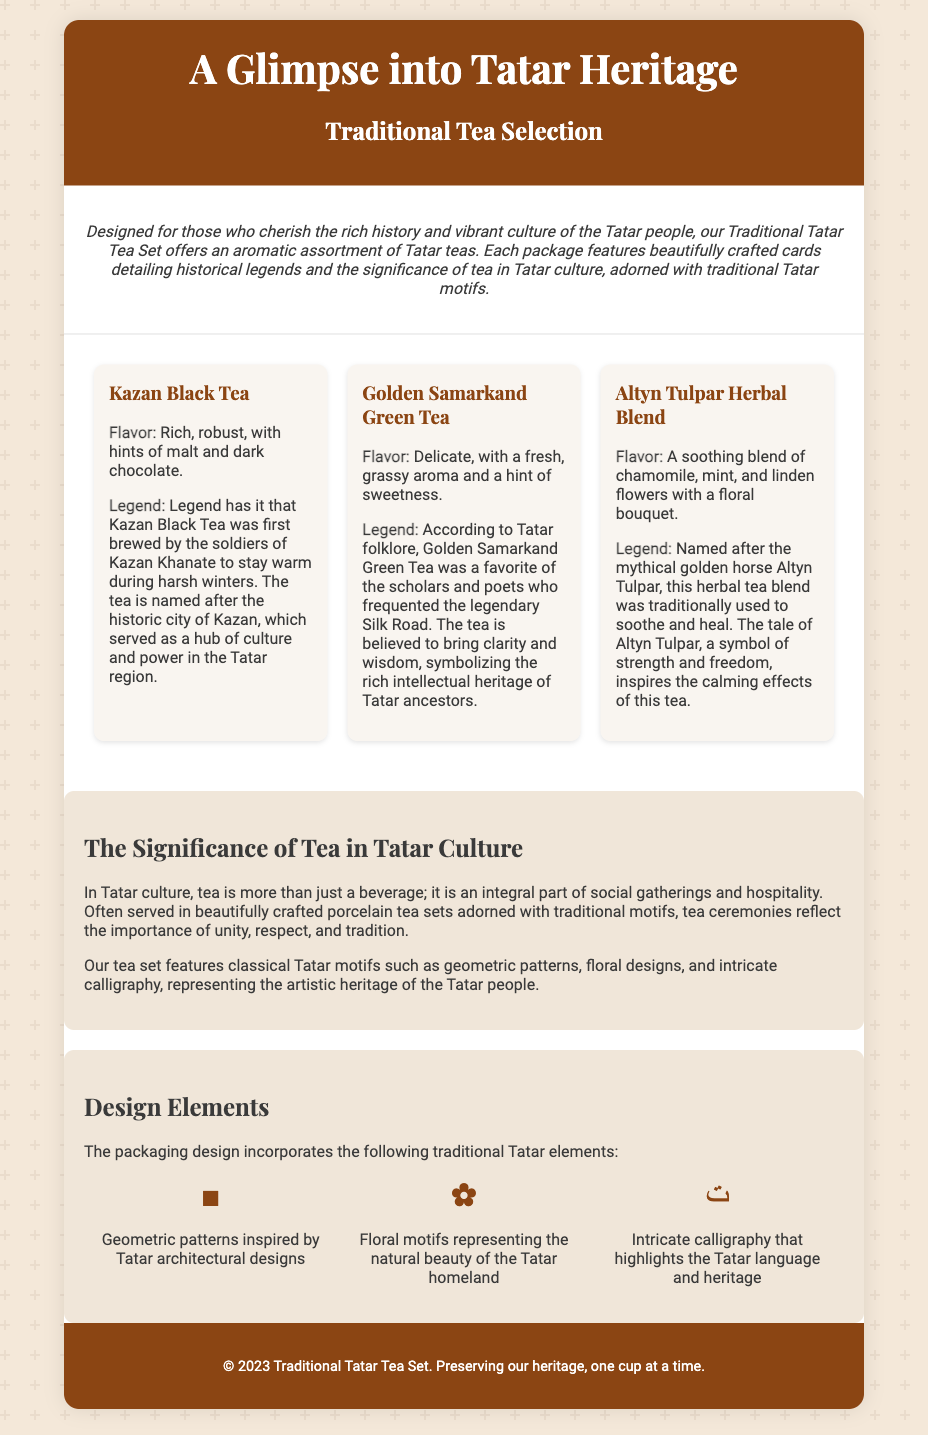What is the title of the product? The title of the product is mentioned at the top of the document, highlighting the traditional tea set and its historical legends.
Answer: Traditional Tatar Tea Set with Historical Legends How many types of tea are included in the set? The document lists three distinct tea types included in the set.
Answer: Three What is the flavor profile of Kazan Black Tea? The flavor profile details are provided in the description of Kazan Black Tea in the document.
Answer: Rich, robust, with hints of malt and dark chocolate What is the significance of tea in Tatar culture? The document explains that tea is an integral part of social gatherings and hospitality in Tatar culture.
Answer: An integral part of social gatherings and hospitality Which motif represents the natural beauty of the Tatar homeland? The document specifies this motif in the design elements section related to Tatar culture.
Answer: Floral motifs What legendary figure is associated with Altyn Tulpar Herbal Blend? The document states that Altyn Tulpar Herbal Blend is named after a mythical figure, as mentioned in the tea description.
Answer: Altyn Tulpar What is the main purpose of the beautifully crafted cards included in the package? The document mentions that the cards provide historical legends and significance of tea in Tatar culture.
Answer: Historical legends and significance of tea What is a common design element in the packaging? The document describes various motifs used in the packaging, highlighting their cultural significance.
Answer: Geometric patterns 